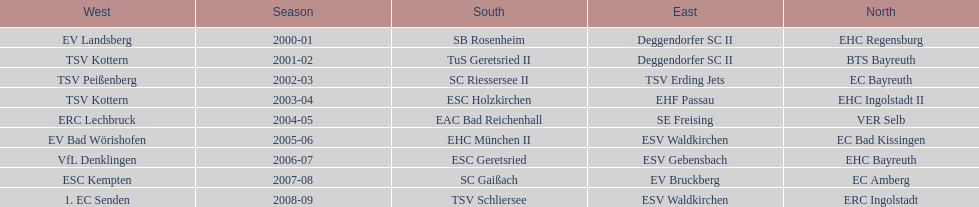Which teams have won in the bavarian ice hockey leagues between 2000 and 2009? EHC Regensburg, SB Rosenheim, Deggendorfer SC II, EV Landsberg, BTS Bayreuth, TuS Geretsried II, TSV Kottern, EC Bayreuth, SC Riessersee II, TSV Erding Jets, TSV Peißenberg, EHC Ingolstadt II, ESC Holzkirchen, EHF Passau, TSV Kottern, VER Selb, EAC Bad Reichenhall, SE Freising, ERC Lechbruck, EC Bad Kissingen, EHC München II, ESV Waldkirchen, EV Bad Wörishofen, EHC Bayreuth, ESC Geretsried, ESV Gebensbach, VfL Denklingen, EC Amberg, SC Gaißach, EV Bruckberg, ESC Kempten, ERC Ingolstadt, TSV Schliersee, ESV Waldkirchen, 1. EC Senden. Which of these winning teams have won the north? EHC Regensburg, BTS Bayreuth, EC Bayreuth, EHC Ingolstadt II, VER Selb, EC Bad Kissingen, EHC Bayreuth, EC Amberg, ERC Ingolstadt. Which of the teams that won the north won in the 2000/2001 season? EHC Regensburg. 